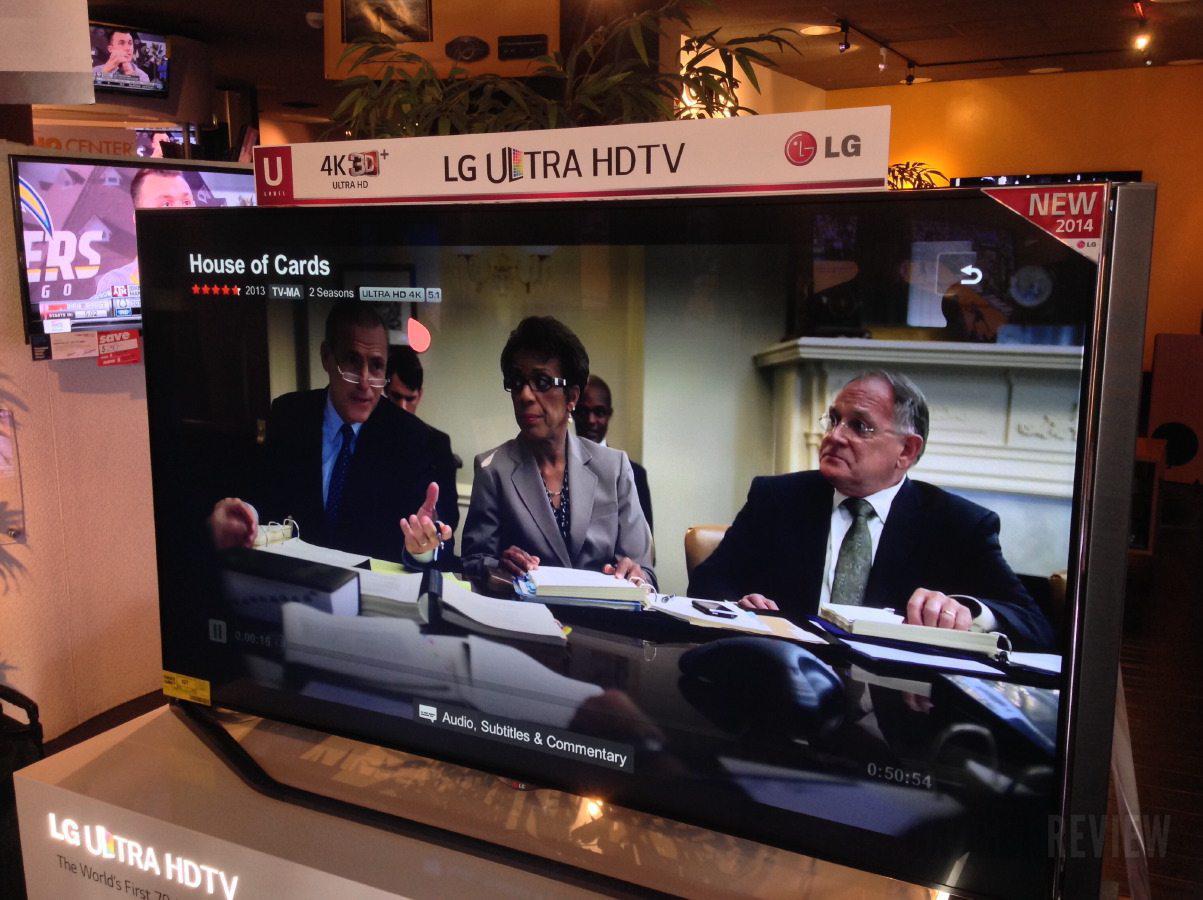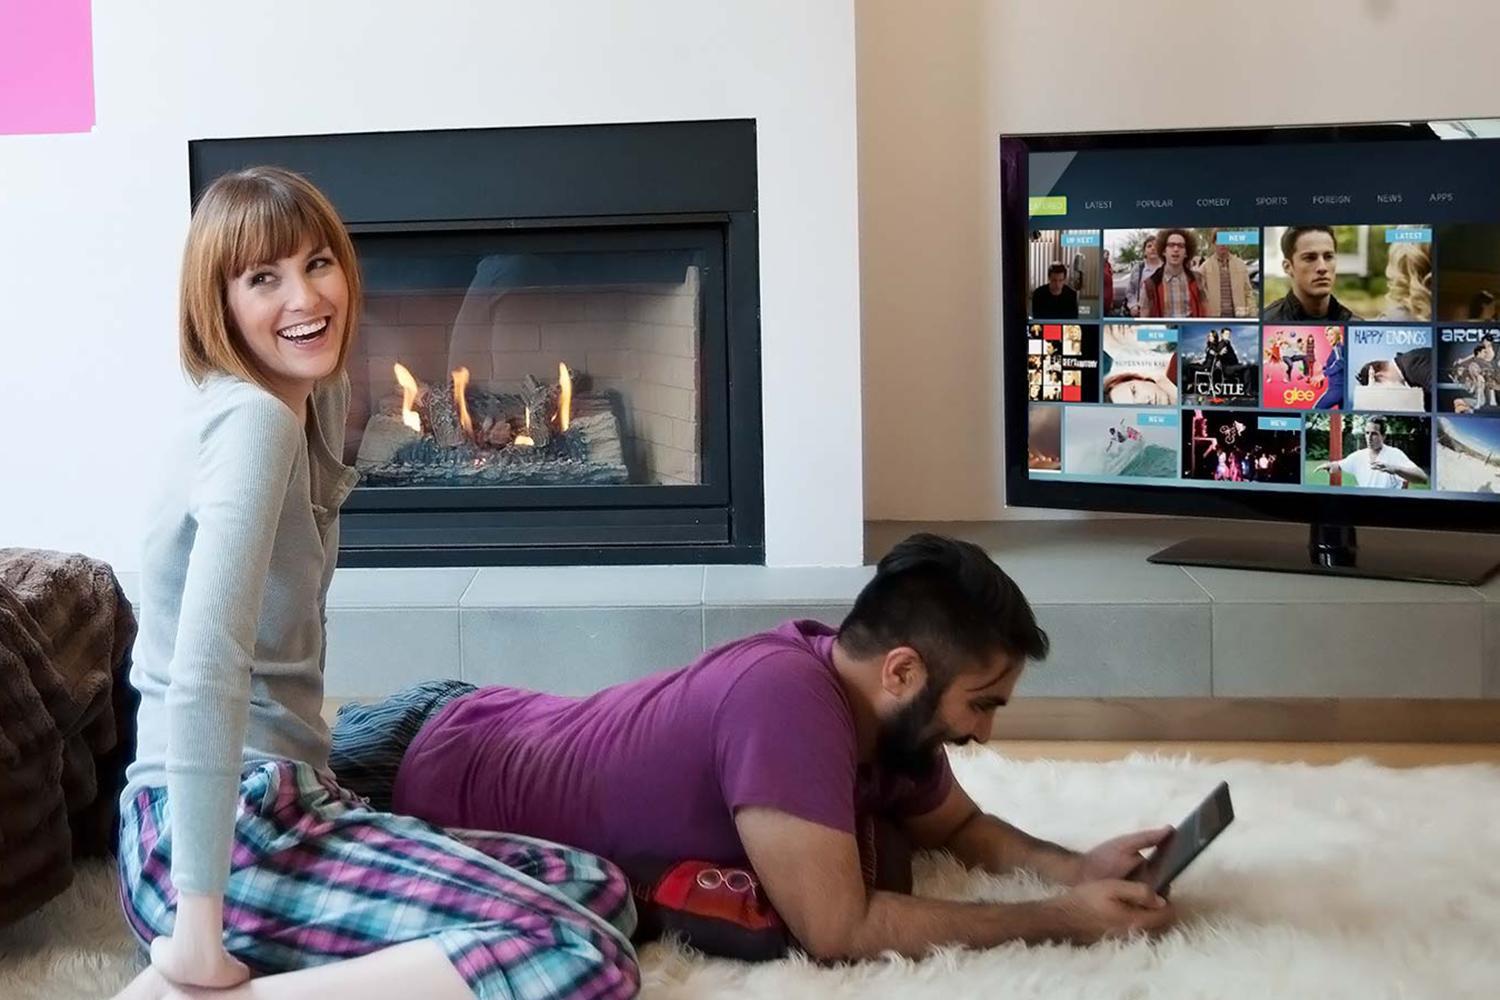The first image is the image on the left, the second image is the image on the right. Evaluate the accuracy of this statement regarding the images: "One of the TVs has a blank green screen.". Is it true? Answer yes or no. No. The first image is the image on the left, the second image is the image on the right. Assess this claim about the two images: "In the right image, a girl sitting on her knees in front of a TV screen has her head turned to look over her shoulder.". Correct or not? Answer yes or no. Yes. 